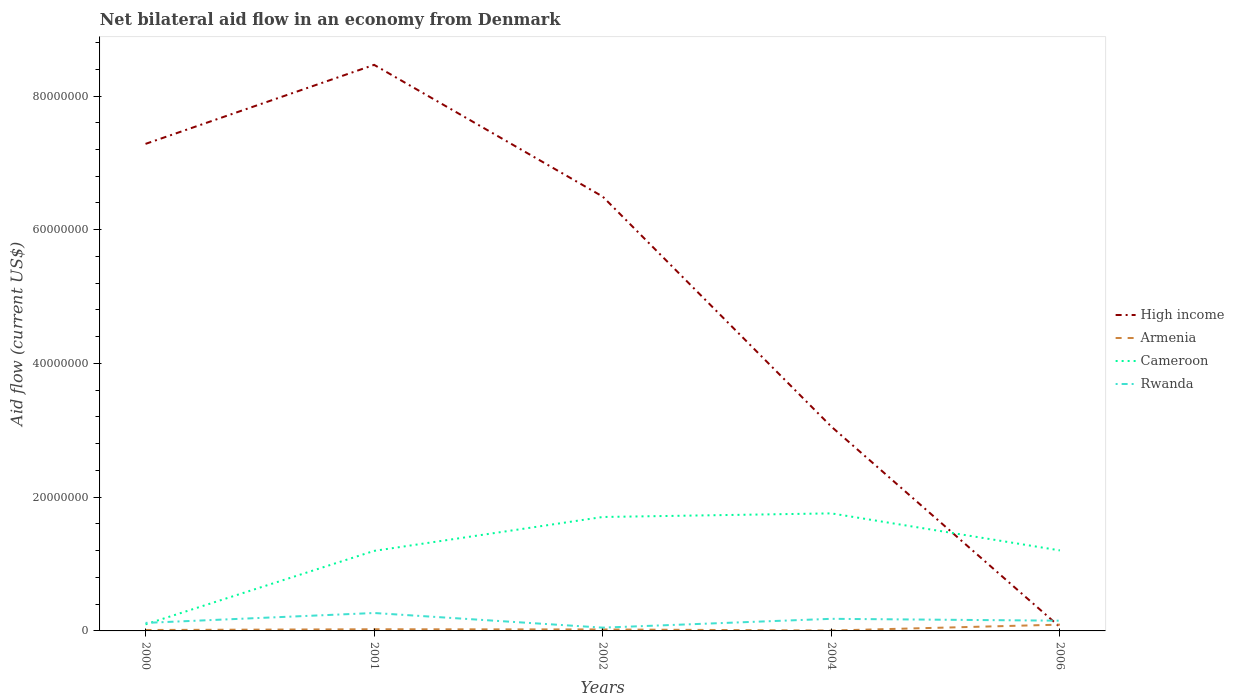Does the line corresponding to Armenia intersect with the line corresponding to Cameroon?
Offer a very short reply. No. Is the number of lines equal to the number of legend labels?
Provide a short and direct response. Yes. In which year was the net bilateral aid flow in Cameroon maximum?
Your answer should be very brief. 2000. What is the total net bilateral aid flow in Armenia in the graph?
Ensure brevity in your answer.  3.00e+04. What is the difference between the highest and the second highest net bilateral aid flow in Armenia?
Offer a very short reply. 8.80e+05. How many years are there in the graph?
Offer a terse response. 5. What is the difference between two consecutive major ticks on the Y-axis?
Make the answer very short. 2.00e+07. Does the graph contain grids?
Give a very brief answer. No. Where does the legend appear in the graph?
Your response must be concise. Center right. How are the legend labels stacked?
Your answer should be very brief. Vertical. What is the title of the graph?
Make the answer very short. Net bilateral aid flow in an economy from Denmark. Does "Hong Kong" appear as one of the legend labels in the graph?
Ensure brevity in your answer.  No. What is the label or title of the X-axis?
Give a very brief answer. Years. What is the label or title of the Y-axis?
Offer a very short reply. Aid flow (current US$). What is the Aid flow (current US$) of High income in 2000?
Provide a succinct answer. 7.28e+07. What is the Aid flow (current US$) in Cameroon in 2000?
Provide a succinct answer. 9.80e+05. What is the Aid flow (current US$) in Rwanda in 2000?
Your answer should be compact. 1.20e+06. What is the Aid flow (current US$) in High income in 2001?
Give a very brief answer. 8.47e+07. What is the Aid flow (current US$) in Armenia in 2001?
Provide a succinct answer. 2.50e+05. What is the Aid flow (current US$) in Cameroon in 2001?
Your answer should be compact. 1.20e+07. What is the Aid flow (current US$) in Rwanda in 2001?
Provide a short and direct response. 2.68e+06. What is the Aid flow (current US$) in High income in 2002?
Ensure brevity in your answer.  6.50e+07. What is the Aid flow (current US$) of Cameroon in 2002?
Your response must be concise. 1.70e+07. What is the Aid flow (current US$) in Rwanda in 2002?
Offer a very short reply. 4.90e+05. What is the Aid flow (current US$) of High income in 2004?
Keep it short and to the point. 3.06e+07. What is the Aid flow (current US$) in Cameroon in 2004?
Keep it short and to the point. 1.76e+07. What is the Aid flow (current US$) in Rwanda in 2004?
Offer a very short reply. 1.81e+06. What is the Aid flow (current US$) in High income in 2006?
Provide a succinct answer. 5.80e+05. What is the Aid flow (current US$) in Armenia in 2006?
Keep it short and to the point. 9.40e+05. What is the Aid flow (current US$) in Cameroon in 2006?
Your answer should be very brief. 1.20e+07. What is the Aid flow (current US$) of Rwanda in 2006?
Your answer should be compact. 1.53e+06. Across all years, what is the maximum Aid flow (current US$) in High income?
Your response must be concise. 8.47e+07. Across all years, what is the maximum Aid flow (current US$) in Armenia?
Provide a succinct answer. 9.40e+05. Across all years, what is the maximum Aid flow (current US$) of Cameroon?
Your response must be concise. 1.76e+07. Across all years, what is the maximum Aid flow (current US$) of Rwanda?
Offer a terse response. 2.68e+06. Across all years, what is the minimum Aid flow (current US$) in High income?
Give a very brief answer. 5.80e+05. Across all years, what is the minimum Aid flow (current US$) in Cameroon?
Your answer should be very brief. 9.80e+05. What is the total Aid flow (current US$) in High income in the graph?
Your response must be concise. 2.54e+08. What is the total Aid flow (current US$) of Armenia in the graph?
Ensure brevity in your answer.  1.61e+06. What is the total Aid flow (current US$) of Cameroon in the graph?
Your answer should be compact. 5.96e+07. What is the total Aid flow (current US$) in Rwanda in the graph?
Provide a short and direct response. 7.71e+06. What is the difference between the Aid flow (current US$) of High income in 2000 and that in 2001?
Your answer should be very brief. -1.18e+07. What is the difference between the Aid flow (current US$) of Armenia in 2000 and that in 2001?
Ensure brevity in your answer.  -1.10e+05. What is the difference between the Aid flow (current US$) of Cameroon in 2000 and that in 2001?
Make the answer very short. -1.10e+07. What is the difference between the Aid flow (current US$) of Rwanda in 2000 and that in 2001?
Provide a short and direct response. -1.48e+06. What is the difference between the Aid flow (current US$) of High income in 2000 and that in 2002?
Your response must be concise. 7.88e+06. What is the difference between the Aid flow (current US$) in Cameroon in 2000 and that in 2002?
Keep it short and to the point. -1.61e+07. What is the difference between the Aid flow (current US$) of Rwanda in 2000 and that in 2002?
Ensure brevity in your answer.  7.10e+05. What is the difference between the Aid flow (current US$) of High income in 2000 and that in 2004?
Provide a short and direct response. 4.23e+07. What is the difference between the Aid flow (current US$) of Armenia in 2000 and that in 2004?
Offer a terse response. 8.00e+04. What is the difference between the Aid flow (current US$) in Cameroon in 2000 and that in 2004?
Offer a terse response. -1.66e+07. What is the difference between the Aid flow (current US$) of Rwanda in 2000 and that in 2004?
Give a very brief answer. -6.10e+05. What is the difference between the Aid flow (current US$) of High income in 2000 and that in 2006?
Your answer should be compact. 7.23e+07. What is the difference between the Aid flow (current US$) in Armenia in 2000 and that in 2006?
Give a very brief answer. -8.00e+05. What is the difference between the Aid flow (current US$) of Cameroon in 2000 and that in 2006?
Offer a terse response. -1.11e+07. What is the difference between the Aid flow (current US$) in Rwanda in 2000 and that in 2006?
Make the answer very short. -3.30e+05. What is the difference between the Aid flow (current US$) in High income in 2001 and that in 2002?
Your answer should be compact. 1.97e+07. What is the difference between the Aid flow (current US$) of Cameroon in 2001 and that in 2002?
Keep it short and to the point. -5.07e+06. What is the difference between the Aid flow (current US$) of Rwanda in 2001 and that in 2002?
Give a very brief answer. 2.19e+06. What is the difference between the Aid flow (current US$) of High income in 2001 and that in 2004?
Provide a succinct answer. 5.41e+07. What is the difference between the Aid flow (current US$) of Cameroon in 2001 and that in 2004?
Offer a very short reply. -5.61e+06. What is the difference between the Aid flow (current US$) of Rwanda in 2001 and that in 2004?
Your answer should be compact. 8.70e+05. What is the difference between the Aid flow (current US$) of High income in 2001 and that in 2006?
Make the answer very short. 8.41e+07. What is the difference between the Aid flow (current US$) in Armenia in 2001 and that in 2006?
Keep it short and to the point. -6.90e+05. What is the difference between the Aid flow (current US$) of Rwanda in 2001 and that in 2006?
Your answer should be very brief. 1.15e+06. What is the difference between the Aid flow (current US$) of High income in 2002 and that in 2004?
Provide a succinct answer. 3.44e+07. What is the difference between the Aid flow (current US$) in Cameroon in 2002 and that in 2004?
Your response must be concise. -5.40e+05. What is the difference between the Aid flow (current US$) of Rwanda in 2002 and that in 2004?
Offer a very short reply. -1.32e+06. What is the difference between the Aid flow (current US$) of High income in 2002 and that in 2006?
Give a very brief answer. 6.44e+07. What is the difference between the Aid flow (current US$) of Armenia in 2002 and that in 2006?
Give a very brief answer. -7.20e+05. What is the difference between the Aid flow (current US$) in Rwanda in 2002 and that in 2006?
Make the answer very short. -1.04e+06. What is the difference between the Aid flow (current US$) of High income in 2004 and that in 2006?
Give a very brief answer. 3.00e+07. What is the difference between the Aid flow (current US$) in Armenia in 2004 and that in 2006?
Keep it short and to the point. -8.80e+05. What is the difference between the Aid flow (current US$) of Cameroon in 2004 and that in 2006?
Make the answer very short. 5.54e+06. What is the difference between the Aid flow (current US$) in Rwanda in 2004 and that in 2006?
Offer a terse response. 2.80e+05. What is the difference between the Aid flow (current US$) in High income in 2000 and the Aid flow (current US$) in Armenia in 2001?
Make the answer very short. 7.26e+07. What is the difference between the Aid flow (current US$) of High income in 2000 and the Aid flow (current US$) of Cameroon in 2001?
Make the answer very short. 6.09e+07. What is the difference between the Aid flow (current US$) in High income in 2000 and the Aid flow (current US$) in Rwanda in 2001?
Provide a succinct answer. 7.02e+07. What is the difference between the Aid flow (current US$) in Armenia in 2000 and the Aid flow (current US$) in Cameroon in 2001?
Keep it short and to the point. -1.18e+07. What is the difference between the Aid flow (current US$) of Armenia in 2000 and the Aid flow (current US$) of Rwanda in 2001?
Provide a succinct answer. -2.54e+06. What is the difference between the Aid flow (current US$) of Cameroon in 2000 and the Aid flow (current US$) of Rwanda in 2001?
Offer a very short reply. -1.70e+06. What is the difference between the Aid flow (current US$) of High income in 2000 and the Aid flow (current US$) of Armenia in 2002?
Give a very brief answer. 7.26e+07. What is the difference between the Aid flow (current US$) of High income in 2000 and the Aid flow (current US$) of Cameroon in 2002?
Your answer should be compact. 5.58e+07. What is the difference between the Aid flow (current US$) of High income in 2000 and the Aid flow (current US$) of Rwanda in 2002?
Offer a very short reply. 7.24e+07. What is the difference between the Aid flow (current US$) in Armenia in 2000 and the Aid flow (current US$) in Cameroon in 2002?
Offer a very short reply. -1.69e+07. What is the difference between the Aid flow (current US$) in Armenia in 2000 and the Aid flow (current US$) in Rwanda in 2002?
Offer a terse response. -3.50e+05. What is the difference between the Aid flow (current US$) of Cameroon in 2000 and the Aid flow (current US$) of Rwanda in 2002?
Keep it short and to the point. 4.90e+05. What is the difference between the Aid flow (current US$) of High income in 2000 and the Aid flow (current US$) of Armenia in 2004?
Give a very brief answer. 7.28e+07. What is the difference between the Aid flow (current US$) in High income in 2000 and the Aid flow (current US$) in Cameroon in 2004?
Provide a succinct answer. 5.53e+07. What is the difference between the Aid flow (current US$) in High income in 2000 and the Aid flow (current US$) in Rwanda in 2004?
Ensure brevity in your answer.  7.10e+07. What is the difference between the Aid flow (current US$) of Armenia in 2000 and the Aid flow (current US$) of Cameroon in 2004?
Provide a short and direct response. -1.74e+07. What is the difference between the Aid flow (current US$) of Armenia in 2000 and the Aid flow (current US$) of Rwanda in 2004?
Your answer should be very brief. -1.67e+06. What is the difference between the Aid flow (current US$) in Cameroon in 2000 and the Aid flow (current US$) in Rwanda in 2004?
Give a very brief answer. -8.30e+05. What is the difference between the Aid flow (current US$) of High income in 2000 and the Aid flow (current US$) of Armenia in 2006?
Your response must be concise. 7.19e+07. What is the difference between the Aid flow (current US$) in High income in 2000 and the Aid flow (current US$) in Cameroon in 2006?
Your answer should be compact. 6.08e+07. What is the difference between the Aid flow (current US$) of High income in 2000 and the Aid flow (current US$) of Rwanda in 2006?
Offer a very short reply. 7.13e+07. What is the difference between the Aid flow (current US$) of Armenia in 2000 and the Aid flow (current US$) of Cameroon in 2006?
Provide a short and direct response. -1.19e+07. What is the difference between the Aid flow (current US$) in Armenia in 2000 and the Aid flow (current US$) in Rwanda in 2006?
Your answer should be very brief. -1.39e+06. What is the difference between the Aid flow (current US$) in Cameroon in 2000 and the Aid flow (current US$) in Rwanda in 2006?
Your answer should be very brief. -5.50e+05. What is the difference between the Aid flow (current US$) of High income in 2001 and the Aid flow (current US$) of Armenia in 2002?
Provide a succinct answer. 8.44e+07. What is the difference between the Aid flow (current US$) in High income in 2001 and the Aid flow (current US$) in Cameroon in 2002?
Make the answer very short. 6.76e+07. What is the difference between the Aid flow (current US$) of High income in 2001 and the Aid flow (current US$) of Rwanda in 2002?
Your answer should be compact. 8.42e+07. What is the difference between the Aid flow (current US$) of Armenia in 2001 and the Aid flow (current US$) of Cameroon in 2002?
Ensure brevity in your answer.  -1.68e+07. What is the difference between the Aid flow (current US$) of Armenia in 2001 and the Aid flow (current US$) of Rwanda in 2002?
Your answer should be compact. -2.40e+05. What is the difference between the Aid flow (current US$) of Cameroon in 2001 and the Aid flow (current US$) of Rwanda in 2002?
Ensure brevity in your answer.  1.15e+07. What is the difference between the Aid flow (current US$) of High income in 2001 and the Aid flow (current US$) of Armenia in 2004?
Your answer should be compact. 8.46e+07. What is the difference between the Aid flow (current US$) of High income in 2001 and the Aid flow (current US$) of Cameroon in 2004?
Your answer should be very brief. 6.71e+07. What is the difference between the Aid flow (current US$) in High income in 2001 and the Aid flow (current US$) in Rwanda in 2004?
Keep it short and to the point. 8.28e+07. What is the difference between the Aid flow (current US$) in Armenia in 2001 and the Aid flow (current US$) in Cameroon in 2004?
Keep it short and to the point. -1.73e+07. What is the difference between the Aid flow (current US$) of Armenia in 2001 and the Aid flow (current US$) of Rwanda in 2004?
Offer a very short reply. -1.56e+06. What is the difference between the Aid flow (current US$) of Cameroon in 2001 and the Aid flow (current US$) of Rwanda in 2004?
Ensure brevity in your answer.  1.02e+07. What is the difference between the Aid flow (current US$) of High income in 2001 and the Aid flow (current US$) of Armenia in 2006?
Make the answer very short. 8.37e+07. What is the difference between the Aid flow (current US$) of High income in 2001 and the Aid flow (current US$) of Cameroon in 2006?
Ensure brevity in your answer.  7.26e+07. What is the difference between the Aid flow (current US$) of High income in 2001 and the Aid flow (current US$) of Rwanda in 2006?
Offer a terse response. 8.31e+07. What is the difference between the Aid flow (current US$) of Armenia in 2001 and the Aid flow (current US$) of Cameroon in 2006?
Give a very brief answer. -1.18e+07. What is the difference between the Aid flow (current US$) of Armenia in 2001 and the Aid flow (current US$) of Rwanda in 2006?
Make the answer very short. -1.28e+06. What is the difference between the Aid flow (current US$) of Cameroon in 2001 and the Aid flow (current US$) of Rwanda in 2006?
Keep it short and to the point. 1.04e+07. What is the difference between the Aid flow (current US$) in High income in 2002 and the Aid flow (current US$) in Armenia in 2004?
Your answer should be compact. 6.49e+07. What is the difference between the Aid flow (current US$) of High income in 2002 and the Aid flow (current US$) of Cameroon in 2004?
Make the answer very short. 4.74e+07. What is the difference between the Aid flow (current US$) in High income in 2002 and the Aid flow (current US$) in Rwanda in 2004?
Provide a succinct answer. 6.32e+07. What is the difference between the Aid flow (current US$) of Armenia in 2002 and the Aid flow (current US$) of Cameroon in 2004?
Make the answer very short. -1.74e+07. What is the difference between the Aid flow (current US$) in Armenia in 2002 and the Aid flow (current US$) in Rwanda in 2004?
Provide a succinct answer. -1.59e+06. What is the difference between the Aid flow (current US$) of Cameroon in 2002 and the Aid flow (current US$) of Rwanda in 2004?
Your answer should be very brief. 1.52e+07. What is the difference between the Aid flow (current US$) in High income in 2002 and the Aid flow (current US$) in Armenia in 2006?
Offer a terse response. 6.40e+07. What is the difference between the Aid flow (current US$) in High income in 2002 and the Aid flow (current US$) in Cameroon in 2006?
Provide a short and direct response. 5.29e+07. What is the difference between the Aid flow (current US$) in High income in 2002 and the Aid flow (current US$) in Rwanda in 2006?
Your answer should be compact. 6.34e+07. What is the difference between the Aid flow (current US$) in Armenia in 2002 and the Aid flow (current US$) in Cameroon in 2006?
Ensure brevity in your answer.  -1.18e+07. What is the difference between the Aid flow (current US$) of Armenia in 2002 and the Aid flow (current US$) of Rwanda in 2006?
Make the answer very short. -1.31e+06. What is the difference between the Aid flow (current US$) in Cameroon in 2002 and the Aid flow (current US$) in Rwanda in 2006?
Provide a succinct answer. 1.55e+07. What is the difference between the Aid flow (current US$) of High income in 2004 and the Aid flow (current US$) of Armenia in 2006?
Keep it short and to the point. 2.96e+07. What is the difference between the Aid flow (current US$) of High income in 2004 and the Aid flow (current US$) of Cameroon in 2006?
Offer a terse response. 1.85e+07. What is the difference between the Aid flow (current US$) in High income in 2004 and the Aid flow (current US$) in Rwanda in 2006?
Your answer should be compact. 2.90e+07. What is the difference between the Aid flow (current US$) in Armenia in 2004 and the Aid flow (current US$) in Cameroon in 2006?
Give a very brief answer. -1.20e+07. What is the difference between the Aid flow (current US$) in Armenia in 2004 and the Aid flow (current US$) in Rwanda in 2006?
Your answer should be compact. -1.47e+06. What is the difference between the Aid flow (current US$) of Cameroon in 2004 and the Aid flow (current US$) of Rwanda in 2006?
Offer a very short reply. 1.60e+07. What is the average Aid flow (current US$) of High income per year?
Make the answer very short. 5.07e+07. What is the average Aid flow (current US$) in Armenia per year?
Make the answer very short. 3.22e+05. What is the average Aid flow (current US$) in Cameroon per year?
Provide a succinct answer. 1.19e+07. What is the average Aid flow (current US$) in Rwanda per year?
Ensure brevity in your answer.  1.54e+06. In the year 2000, what is the difference between the Aid flow (current US$) in High income and Aid flow (current US$) in Armenia?
Provide a succinct answer. 7.27e+07. In the year 2000, what is the difference between the Aid flow (current US$) of High income and Aid flow (current US$) of Cameroon?
Provide a short and direct response. 7.19e+07. In the year 2000, what is the difference between the Aid flow (current US$) of High income and Aid flow (current US$) of Rwanda?
Make the answer very short. 7.16e+07. In the year 2000, what is the difference between the Aid flow (current US$) of Armenia and Aid flow (current US$) of Cameroon?
Provide a short and direct response. -8.40e+05. In the year 2000, what is the difference between the Aid flow (current US$) in Armenia and Aid flow (current US$) in Rwanda?
Provide a short and direct response. -1.06e+06. In the year 2000, what is the difference between the Aid flow (current US$) in Cameroon and Aid flow (current US$) in Rwanda?
Provide a succinct answer. -2.20e+05. In the year 2001, what is the difference between the Aid flow (current US$) in High income and Aid flow (current US$) in Armenia?
Provide a succinct answer. 8.44e+07. In the year 2001, what is the difference between the Aid flow (current US$) of High income and Aid flow (current US$) of Cameroon?
Offer a very short reply. 7.27e+07. In the year 2001, what is the difference between the Aid flow (current US$) in High income and Aid flow (current US$) in Rwanda?
Make the answer very short. 8.20e+07. In the year 2001, what is the difference between the Aid flow (current US$) of Armenia and Aid flow (current US$) of Cameroon?
Keep it short and to the point. -1.17e+07. In the year 2001, what is the difference between the Aid flow (current US$) in Armenia and Aid flow (current US$) in Rwanda?
Ensure brevity in your answer.  -2.43e+06. In the year 2001, what is the difference between the Aid flow (current US$) in Cameroon and Aid flow (current US$) in Rwanda?
Offer a very short reply. 9.29e+06. In the year 2002, what is the difference between the Aid flow (current US$) of High income and Aid flow (current US$) of Armenia?
Keep it short and to the point. 6.47e+07. In the year 2002, what is the difference between the Aid flow (current US$) of High income and Aid flow (current US$) of Cameroon?
Your response must be concise. 4.79e+07. In the year 2002, what is the difference between the Aid flow (current US$) of High income and Aid flow (current US$) of Rwanda?
Offer a terse response. 6.45e+07. In the year 2002, what is the difference between the Aid flow (current US$) of Armenia and Aid flow (current US$) of Cameroon?
Your answer should be compact. -1.68e+07. In the year 2002, what is the difference between the Aid flow (current US$) of Cameroon and Aid flow (current US$) of Rwanda?
Your response must be concise. 1.66e+07. In the year 2004, what is the difference between the Aid flow (current US$) of High income and Aid flow (current US$) of Armenia?
Provide a succinct answer. 3.05e+07. In the year 2004, what is the difference between the Aid flow (current US$) of High income and Aid flow (current US$) of Cameroon?
Give a very brief answer. 1.30e+07. In the year 2004, what is the difference between the Aid flow (current US$) of High income and Aid flow (current US$) of Rwanda?
Make the answer very short. 2.88e+07. In the year 2004, what is the difference between the Aid flow (current US$) in Armenia and Aid flow (current US$) in Cameroon?
Offer a terse response. -1.75e+07. In the year 2004, what is the difference between the Aid flow (current US$) in Armenia and Aid flow (current US$) in Rwanda?
Give a very brief answer. -1.75e+06. In the year 2004, what is the difference between the Aid flow (current US$) of Cameroon and Aid flow (current US$) of Rwanda?
Offer a terse response. 1.58e+07. In the year 2006, what is the difference between the Aid flow (current US$) in High income and Aid flow (current US$) in Armenia?
Make the answer very short. -3.60e+05. In the year 2006, what is the difference between the Aid flow (current US$) of High income and Aid flow (current US$) of Cameroon?
Ensure brevity in your answer.  -1.15e+07. In the year 2006, what is the difference between the Aid flow (current US$) of High income and Aid flow (current US$) of Rwanda?
Offer a terse response. -9.50e+05. In the year 2006, what is the difference between the Aid flow (current US$) in Armenia and Aid flow (current US$) in Cameroon?
Give a very brief answer. -1.11e+07. In the year 2006, what is the difference between the Aid flow (current US$) of Armenia and Aid flow (current US$) of Rwanda?
Give a very brief answer. -5.90e+05. In the year 2006, what is the difference between the Aid flow (current US$) of Cameroon and Aid flow (current US$) of Rwanda?
Your response must be concise. 1.05e+07. What is the ratio of the Aid flow (current US$) in High income in 2000 to that in 2001?
Your response must be concise. 0.86. What is the ratio of the Aid flow (current US$) of Armenia in 2000 to that in 2001?
Your answer should be compact. 0.56. What is the ratio of the Aid flow (current US$) in Cameroon in 2000 to that in 2001?
Give a very brief answer. 0.08. What is the ratio of the Aid flow (current US$) of Rwanda in 2000 to that in 2001?
Give a very brief answer. 0.45. What is the ratio of the Aid flow (current US$) of High income in 2000 to that in 2002?
Your answer should be compact. 1.12. What is the ratio of the Aid flow (current US$) of Armenia in 2000 to that in 2002?
Ensure brevity in your answer.  0.64. What is the ratio of the Aid flow (current US$) in Cameroon in 2000 to that in 2002?
Provide a short and direct response. 0.06. What is the ratio of the Aid flow (current US$) in Rwanda in 2000 to that in 2002?
Your answer should be compact. 2.45. What is the ratio of the Aid flow (current US$) in High income in 2000 to that in 2004?
Provide a short and direct response. 2.38. What is the ratio of the Aid flow (current US$) in Armenia in 2000 to that in 2004?
Make the answer very short. 2.33. What is the ratio of the Aid flow (current US$) in Cameroon in 2000 to that in 2004?
Offer a very short reply. 0.06. What is the ratio of the Aid flow (current US$) of Rwanda in 2000 to that in 2004?
Ensure brevity in your answer.  0.66. What is the ratio of the Aid flow (current US$) of High income in 2000 to that in 2006?
Give a very brief answer. 125.59. What is the ratio of the Aid flow (current US$) in Armenia in 2000 to that in 2006?
Your response must be concise. 0.15. What is the ratio of the Aid flow (current US$) of Cameroon in 2000 to that in 2006?
Give a very brief answer. 0.08. What is the ratio of the Aid flow (current US$) in Rwanda in 2000 to that in 2006?
Offer a very short reply. 0.78. What is the ratio of the Aid flow (current US$) of High income in 2001 to that in 2002?
Make the answer very short. 1.3. What is the ratio of the Aid flow (current US$) of Armenia in 2001 to that in 2002?
Keep it short and to the point. 1.14. What is the ratio of the Aid flow (current US$) of Cameroon in 2001 to that in 2002?
Offer a very short reply. 0.7. What is the ratio of the Aid flow (current US$) in Rwanda in 2001 to that in 2002?
Your response must be concise. 5.47. What is the ratio of the Aid flow (current US$) in High income in 2001 to that in 2004?
Keep it short and to the point. 2.77. What is the ratio of the Aid flow (current US$) of Armenia in 2001 to that in 2004?
Offer a very short reply. 4.17. What is the ratio of the Aid flow (current US$) of Cameroon in 2001 to that in 2004?
Provide a succinct answer. 0.68. What is the ratio of the Aid flow (current US$) in Rwanda in 2001 to that in 2004?
Your answer should be very brief. 1.48. What is the ratio of the Aid flow (current US$) in High income in 2001 to that in 2006?
Ensure brevity in your answer.  145.97. What is the ratio of the Aid flow (current US$) in Armenia in 2001 to that in 2006?
Your answer should be very brief. 0.27. What is the ratio of the Aid flow (current US$) in Cameroon in 2001 to that in 2006?
Provide a succinct answer. 0.99. What is the ratio of the Aid flow (current US$) of Rwanda in 2001 to that in 2006?
Your answer should be compact. 1.75. What is the ratio of the Aid flow (current US$) in High income in 2002 to that in 2004?
Your answer should be compact. 2.13. What is the ratio of the Aid flow (current US$) of Armenia in 2002 to that in 2004?
Keep it short and to the point. 3.67. What is the ratio of the Aid flow (current US$) of Cameroon in 2002 to that in 2004?
Your answer should be very brief. 0.97. What is the ratio of the Aid flow (current US$) in Rwanda in 2002 to that in 2004?
Provide a succinct answer. 0.27. What is the ratio of the Aid flow (current US$) of High income in 2002 to that in 2006?
Give a very brief answer. 112. What is the ratio of the Aid flow (current US$) in Armenia in 2002 to that in 2006?
Provide a short and direct response. 0.23. What is the ratio of the Aid flow (current US$) in Cameroon in 2002 to that in 2006?
Ensure brevity in your answer.  1.42. What is the ratio of the Aid flow (current US$) in Rwanda in 2002 to that in 2006?
Your response must be concise. 0.32. What is the ratio of the Aid flow (current US$) in High income in 2004 to that in 2006?
Offer a terse response. 52.69. What is the ratio of the Aid flow (current US$) of Armenia in 2004 to that in 2006?
Ensure brevity in your answer.  0.06. What is the ratio of the Aid flow (current US$) of Cameroon in 2004 to that in 2006?
Keep it short and to the point. 1.46. What is the ratio of the Aid flow (current US$) of Rwanda in 2004 to that in 2006?
Your answer should be very brief. 1.18. What is the difference between the highest and the second highest Aid flow (current US$) in High income?
Provide a succinct answer. 1.18e+07. What is the difference between the highest and the second highest Aid flow (current US$) of Armenia?
Make the answer very short. 6.90e+05. What is the difference between the highest and the second highest Aid flow (current US$) in Cameroon?
Your response must be concise. 5.40e+05. What is the difference between the highest and the second highest Aid flow (current US$) in Rwanda?
Ensure brevity in your answer.  8.70e+05. What is the difference between the highest and the lowest Aid flow (current US$) in High income?
Provide a succinct answer. 8.41e+07. What is the difference between the highest and the lowest Aid flow (current US$) in Armenia?
Give a very brief answer. 8.80e+05. What is the difference between the highest and the lowest Aid flow (current US$) of Cameroon?
Provide a short and direct response. 1.66e+07. What is the difference between the highest and the lowest Aid flow (current US$) in Rwanda?
Give a very brief answer. 2.19e+06. 